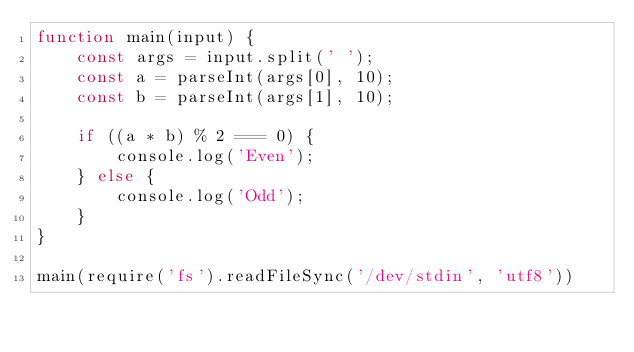Convert code to text. <code><loc_0><loc_0><loc_500><loc_500><_JavaScript_>function main(input) {                                                                                                                                                                                 
    const args = input.split(' ');                                                                                                                                                                     
    const a = parseInt(args[0], 10);                                                                                                                                                                   
    const b = parseInt(args[1], 10);                                                                                                                                                                   
                                                                                                                                                                                                       
    if ((a * b) % 2 === 0) {                                                                                                                                                                           
        console.log('Even');                                                                                                                                                                           
    } else {                                                                                                                                                                                           
        console.log('Odd');                                                                                                                                                                            
    }                                                                                                                                                                                                  
}                                                                                                                                                                                                      
                                                                                                                                                                                                       
main(require('fs').readFileSync('/dev/stdin', 'utf8'))   </code> 